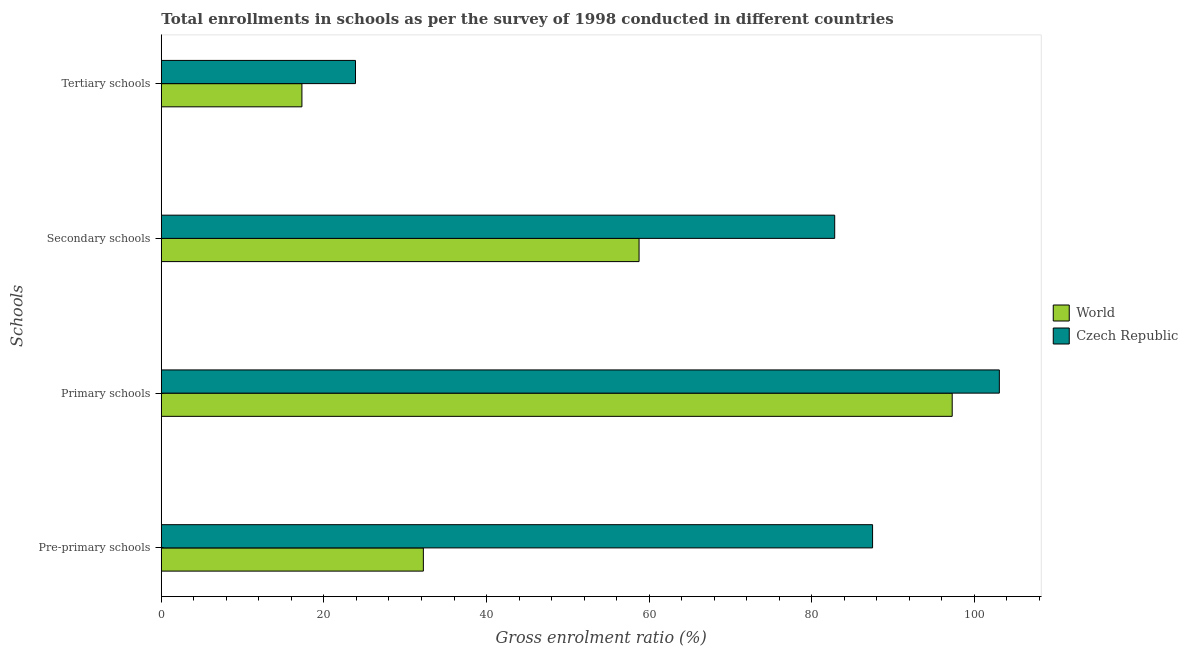How many bars are there on the 1st tick from the top?
Your response must be concise. 2. How many bars are there on the 3rd tick from the bottom?
Your answer should be compact. 2. What is the label of the 1st group of bars from the top?
Give a very brief answer. Tertiary schools. What is the gross enrolment ratio in tertiary schools in Czech Republic?
Offer a terse response. 23.88. Across all countries, what is the maximum gross enrolment ratio in tertiary schools?
Make the answer very short. 23.88. Across all countries, what is the minimum gross enrolment ratio in pre-primary schools?
Provide a succinct answer. 32.23. In which country was the gross enrolment ratio in pre-primary schools maximum?
Provide a succinct answer. Czech Republic. In which country was the gross enrolment ratio in pre-primary schools minimum?
Make the answer very short. World. What is the total gross enrolment ratio in pre-primary schools in the graph?
Provide a succinct answer. 119.7. What is the difference between the gross enrolment ratio in pre-primary schools in Czech Republic and that in World?
Provide a succinct answer. 55.25. What is the difference between the gross enrolment ratio in primary schools in World and the gross enrolment ratio in secondary schools in Czech Republic?
Your answer should be compact. 14.45. What is the average gross enrolment ratio in primary schools per country?
Give a very brief answer. 100.17. What is the difference between the gross enrolment ratio in secondary schools and gross enrolment ratio in pre-primary schools in World?
Make the answer very short. 26.53. What is the ratio of the gross enrolment ratio in secondary schools in Czech Republic to that in World?
Your answer should be very brief. 1.41. What is the difference between the highest and the second highest gross enrolment ratio in tertiary schools?
Make the answer very short. 6.59. What is the difference between the highest and the lowest gross enrolment ratio in tertiary schools?
Provide a short and direct response. 6.59. Is the sum of the gross enrolment ratio in secondary schools in World and Czech Republic greater than the maximum gross enrolment ratio in primary schools across all countries?
Provide a short and direct response. Yes. Is it the case that in every country, the sum of the gross enrolment ratio in primary schools and gross enrolment ratio in tertiary schools is greater than the sum of gross enrolment ratio in secondary schools and gross enrolment ratio in pre-primary schools?
Give a very brief answer. No. What does the 1st bar from the top in Tertiary schools represents?
Your response must be concise. Czech Republic. What does the 2nd bar from the bottom in Secondary schools represents?
Offer a very short reply. Czech Republic. Is it the case that in every country, the sum of the gross enrolment ratio in pre-primary schools and gross enrolment ratio in primary schools is greater than the gross enrolment ratio in secondary schools?
Provide a short and direct response. Yes. How many bars are there?
Ensure brevity in your answer.  8. Are all the bars in the graph horizontal?
Your answer should be very brief. Yes. How many countries are there in the graph?
Ensure brevity in your answer.  2. What is the difference between two consecutive major ticks on the X-axis?
Give a very brief answer. 20. Are the values on the major ticks of X-axis written in scientific E-notation?
Your response must be concise. No. Does the graph contain any zero values?
Offer a very short reply. No. Does the graph contain grids?
Keep it short and to the point. No. How many legend labels are there?
Offer a very short reply. 2. What is the title of the graph?
Your answer should be compact. Total enrollments in schools as per the survey of 1998 conducted in different countries. What is the label or title of the Y-axis?
Offer a terse response. Schools. What is the Gross enrolment ratio (%) in World in Pre-primary schools?
Ensure brevity in your answer.  32.23. What is the Gross enrolment ratio (%) in Czech Republic in Pre-primary schools?
Ensure brevity in your answer.  87.47. What is the Gross enrolment ratio (%) of World in Primary schools?
Give a very brief answer. 97.27. What is the Gross enrolment ratio (%) of Czech Republic in Primary schools?
Your answer should be very brief. 103.07. What is the Gross enrolment ratio (%) in World in Secondary schools?
Make the answer very short. 58.76. What is the Gross enrolment ratio (%) in Czech Republic in Secondary schools?
Offer a very short reply. 82.82. What is the Gross enrolment ratio (%) of World in Tertiary schools?
Your response must be concise. 17.29. What is the Gross enrolment ratio (%) of Czech Republic in Tertiary schools?
Provide a succinct answer. 23.88. Across all Schools, what is the maximum Gross enrolment ratio (%) in World?
Keep it short and to the point. 97.27. Across all Schools, what is the maximum Gross enrolment ratio (%) of Czech Republic?
Your response must be concise. 103.07. Across all Schools, what is the minimum Gross enrolment ratio (%) in World?
Give a very brief answer. 17.29. Across all Schools, what is the minimum Gross enrolment ratio (%) of Czech Republic?
Provide a succinct answer. 23.88. What is the total Gross enrolment ratio (%) in World in the graph?
Ensure brevity in your answer.  205.55. What is the total Gross enrolment ratio (%) of Czech Republic in the graph?
Make the answer very short. 297.24. What is the difference between the Gross enrolment ratio (%) of World in Pre-primary schools and that in Primary schools?
Your answer should be very brief. -65.04. What is the difference between the Gross enrolment ratio (%) in Czech Republic in Pre-primary schools and that in Primary schools?
Offer a very short reply. -15.59. What is the difference between the Gross enrolment ratio (%) of World in Pre-primary schools and that in Secondary schools?
Your response must be concise. -26.53. What is the difference between the Gross enrolment ratio (%) in Czech Republic in Pre-primary schools and that in Secondary schools?
Provide a short and direct response. 4.66. What is the difference between the Gross enrolment ratio (%) of World in Pre-primary schools and that in Tertiary schools?
Your response must be concise. 14.94. What is the difference between the Gross enrolment ratio (%) of Czech Republic in Pre-primary schools and that in Tertiary schools?
Your answer should be compact. 63.59. What is the difference between the Gross enrolment ratio (%) of World in Primary schools and that in Secondary schools?
Offer a very short reply. 38.51. What is the difference between the Gross enrolment ratio (%) in Czech Republic in Primary schools and that in Secondary schools?
Offer a terse response. 20.25. What is the difference between the Gross enrolment ratio (%) in World in Primary schools and that in Tertiary schools?
Provide a succinct answer. 79.97. What is the difference between the Gross enrolment ratio (%) in Czech Republic in Primary schools and that in Tertiary schools?
Make the answer very short. 79.19. What is the difference between the Gross enrolment ratio (%) of World in Secondary schools and that in Tertiary schools?
Your answer should be compact. 41.46. What is the difference between the Gross enrolment ratio (%) of Czech Republic in Secondary schools and that in Tertiary schools?
Make the answer very short. 58.94. What is the difference between the Gross enrolment ratio (%) of World in Pre-primary schools and the Gross enrolment ratio (%) of Czech Republic in Primary schools?
Offer a very short reply. -70.84. What is the difference between the Gross enrolment ratio (%) of World in Pre-primary schools and the Gross enrolment ratio (%) of Czech Republic in Secondary schools?
Give a very brief answer. -50.59. What is the difference between the Gross enrolment ratio (%) of World in Pre-primary schools and the Gross enrolment ratio (%) of Czech Republic in Tertiary schools?
Give a very brief answer. 8.35. What is the difference between the Gross enrolment ratio (%) of World in Primary schools and the Gross enrolment ratio (%) of Czech Republic in Secondary schools?
Provide a short and direct response. 14.45. What is the difference between the Gross enrolment ratio (%) in World in Primary schools and the Gross enrolment ratio (%) in Czech Republic in Tertiary schools?
Your answer should be compact. 73.39. What is the difference between the Gross enrolment ratio (%) in World in Secondary schools and the Gross enrolment ratio (%) in Czech Republic in Tertiary schools?
Give a very brief answer. 34.88. What is the average Gross enrolment ratio (%) of World per Schools?
Your answer should be compact. 51.39. What is the average Gross enrolment ratio (%) of Czech Republic per Schools?
Provide a short and direct response. 74.31. What is the difference between the Gross enrolment ratio (%) in World and Gross enrolment ratio (%) in Czech Republic in Pre-primary schools?
Give a very brief answer. -55.25. What is the difference between the Gross enrolment ratio (%) of World and Gross enrolment ratio (%) of Czech Republic in Primary schools?
Offer a very short reply. -5.8. What is the difference between the Gross enrolment ratio (%) in World and Gross enrolment ratio (%) in Czech Republic in Secondary schools?
Offer a terse response. -24.06. What is the difference between the Gross enrolment ratio (%) of World and Gross enrolment ratio (%) of Czech Republic in Tertiary schools?
Your response must be concise. -6.59. What is the ratio of the Gross enrolment ratio (%) of World in Pre-primary schools to that in Primary schools?
Offer a terse response. 0.33. What is the ratio of the Gross enrolment ratio (%) of Czech Republic in Pre-primary schools to that in Primary schools?
Make the answer very short. 0.85. What is the ratio of the Gross enrolment ratio (%) in World in Pre-primary schools to that in Secondary schools?
Your answer should be compact. 0.55. What is the ratio of the Gross enrolment ratio (%) in Czech Republic in Pre-primary schools to that in Secondary schools?
Provide a short and direct response. 1.06. What is the ratio of the Gross enrolment ratio (%) of World in Pre-primary schools to that in Tertiary schools?
Ensure brevity in your answer.  1.86. What is the ratio of the Gross enrolment ratio (%) of Czech Republic in Pre-primary schools to that in Tertiary schools?
Offer a very short reply. 3.66. What is the ratio of the Gross enrolment ratio (%) in World in Primary schools to that in Secondary schools?
Your response must be concise. 1.66. What is the ratio of the Gross enrolment ratio (%) of Czech Republic in Primary schools to that in Secondary schools?
Your answer should be very brief. 1.24. What is the ratio of the Gross enrolment ratio (%) in World in Primary schools to that in Tertiary schools?
Make the answer very short. 5.62. What is the ratio of the Gross enrolment ratio (%) in Czech Republic in Primary schools to that in Tertiary schools?
Your response must be concise. 4.32. What is the ratio of the Gross enrolment ratio (%) of World in Secondary schools to that in Tertiary schools?
Offer a terse response. 3.4. What is the ratio of the Gross enrolment ratio (%) in Czech Republic in Secondary schools to that in Tertiary schools?
Keep it short and to the point. 3.47. What is the difference between the highest and the second highest Gross enrolment ratio (%) of World?
Your answer should be compact. 38.51. What is the difference between the highest and the second highest Gross enrolment ratio (%) of Czech Republic?
Make the answer very short. 15.59. What is the difference between the highest and the lowest Gross enrolment ratio (%) in World?
Your answer should be very brief. 79.97. What is the difference between the highest and the lowest Gross enrolment ratio (%) of Czech Republic?
Your answer should be very brief. 79.19. 